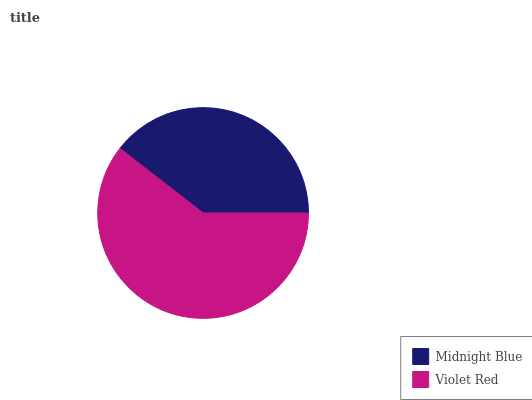Is Midnight Blue the minimum?
Answer yes or no. Yes. Is Violet Red the maximum?
Answer yes or no. Yes. Is Violet Red the minimum?
Answer yes or no. No. Is Violet Red greater than Midnight Blue?
Answer yes or no. Yes. Is Midnight Blue less than Violet Red?
Answer yes or no. Yes. Is Midnight Blue greater than Violet Red?
Answer yes or no. No. Is Violet Red less than Midnight Blue?
Answer yes or no. No. Is Violet Red the high median?
Answer yes or no. Yes. Is Midnight Blue the low median?
Answer yes or no. Yes. Is Midnight Blue the high median?
Answer yes or no. No. Is Violet Red the low median?
Answer yes or no. No. 